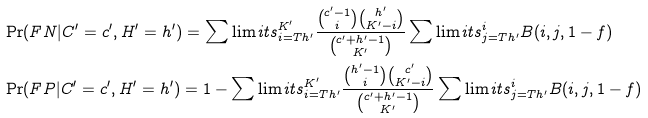Convert formula to latex. <formula><loc_0><loc_0><loc_500><loc_500>& \Pr ( F N | C ^ { \prime } = c ^ { \prime } , H ^ { \prime } = h ^ { \prime } ) = \sum \lim i t s _ { i = T h ^ { \prime } } ^ { K ^ { \prime } } \frac { \binom { c ^ { \prime } - 1 } { i } \binom { h ^ { \prime } } { K ^ { \prime } - i } } { \binom { c ^ { \prime } + h ^ { \prime } - 1 } { K ^ { \prime } } } \sum \lim i t s _ { j = T h ^ { \prime } } ^ { i } B ( i , j , 1 - f ) \\ & \Pr ( F P | C ^ { \prime } = c ^ { \prime } , H ^ { \prime } = h ^ { \prime } ) = 1 - \sum \lim i t s _ { i = T h ^ { \prime } } ^ { K ^ { \prime } } \frac { \binom { h ^ { \prime } - 1 } { i } \binom { c ^ { \prime } } { K ^ { \prime } - i } } { \binom { c ^ { \prime } + h ^ { \prime } - 1 } { K ^ { \prime } } } \sum \lim i t s _ { j = T h ^ { \prime } } ^ { i } B ( i , j , 1 - f )</formula> 